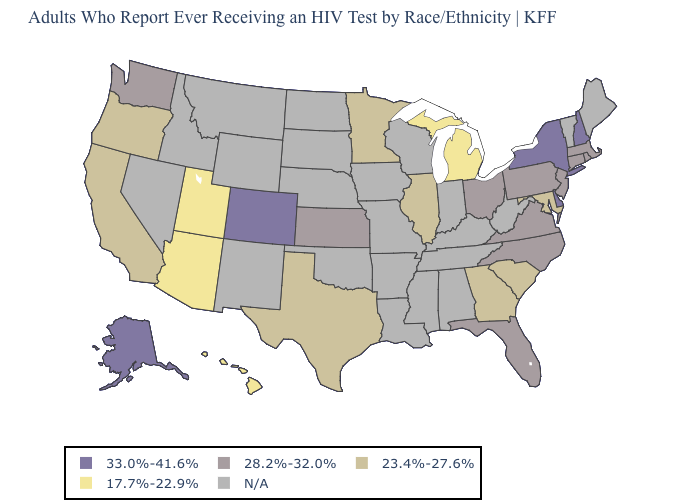Name the states that have a value in the range 28.2%-32.0%?
Concise answer only. Connecticut, Florida, Kansas, Massachusetts, New Jersey, North Carolina, Ohio, Pennsylvania, Rhode Island, Virginia, Washington. Is the legend a continuous bar?
Quick response, please. No. What is the value of Wyoming?
Give a very brief answer. N/A. Is the legend a continuous bar?
Answer briefly. No. Does Kansas have the highest value in the MidWest?
Write a very short answer. Yes. Name the states that have a value in the range 33.0%-41.6%?
Quick response, please. Alaska, Colorado, Delaware, New Hampshire, New York. Name the states that have a value in the range 23.4%-27.6%?
Write a very short answer. California, Georgia, Illinois, Maryland, Minnesota, Oregon, South Carolina, Texas. What is the lowest value in the Northeast?
Keep it brief. 28.2%-32.0%. What is the lowest value in the MidWest?
Concise answer only. 17.7%-22.9%. What is the value of Arizona?
Give a very brief answer. 17.7%-22.9%. 